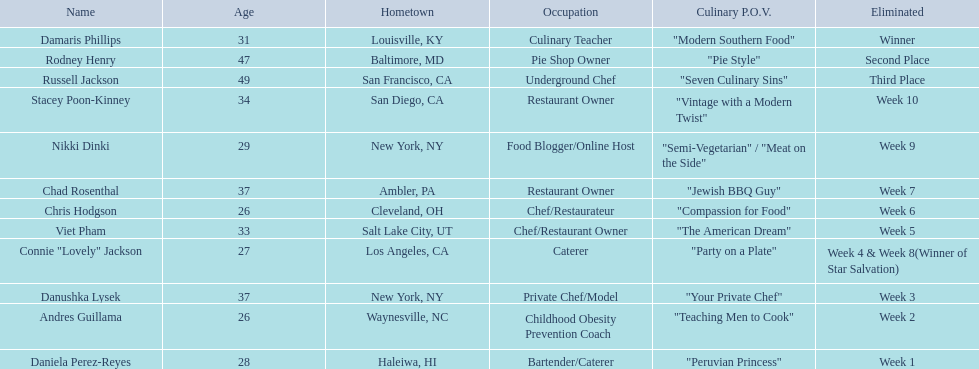What was the number of competitors below 30 years old? 5. 